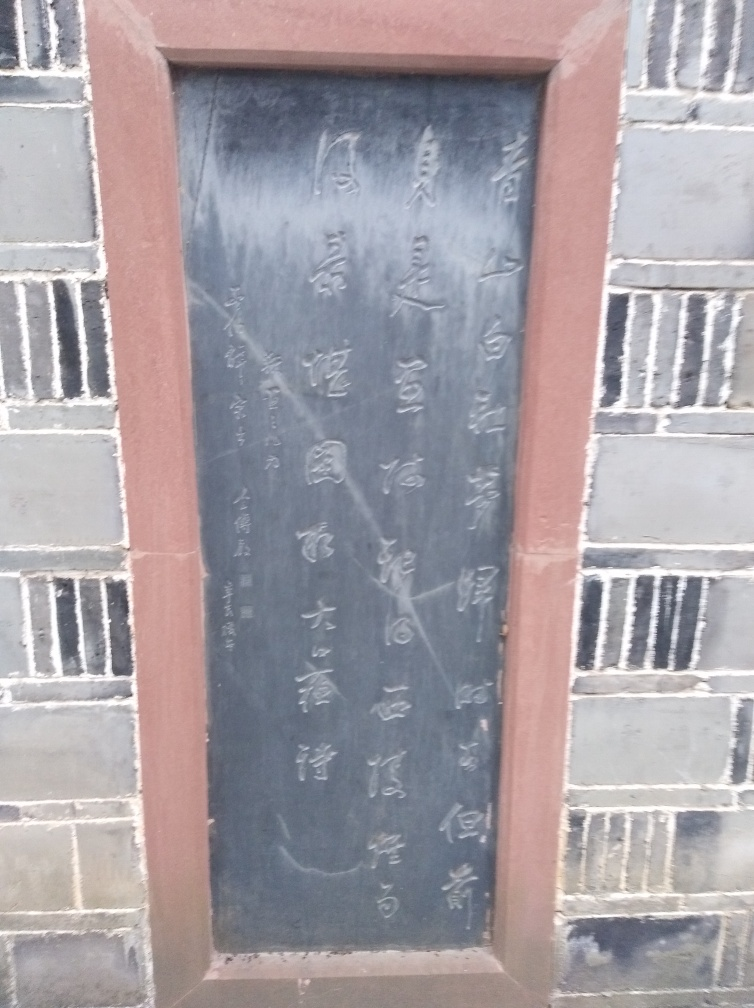Is there anything interesting about the construction or design of the tablet itself? The tablet is framed with a simple yet elegant border, suggesting it is an item of significance, likely placed there to be seen and read by passersby. Its dark surface contrasts with the lighter characters, and although the image doesn't show high clarity, we can tell that the tablet's material has a reflective sheen, which could indicate polished stone or metal. 